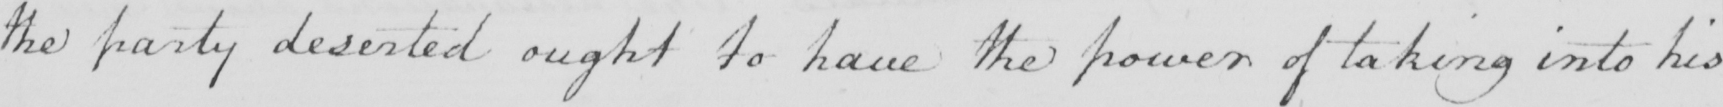Can you tell me what this handwritten text says? the party deserted ought to have the power of taking into his 